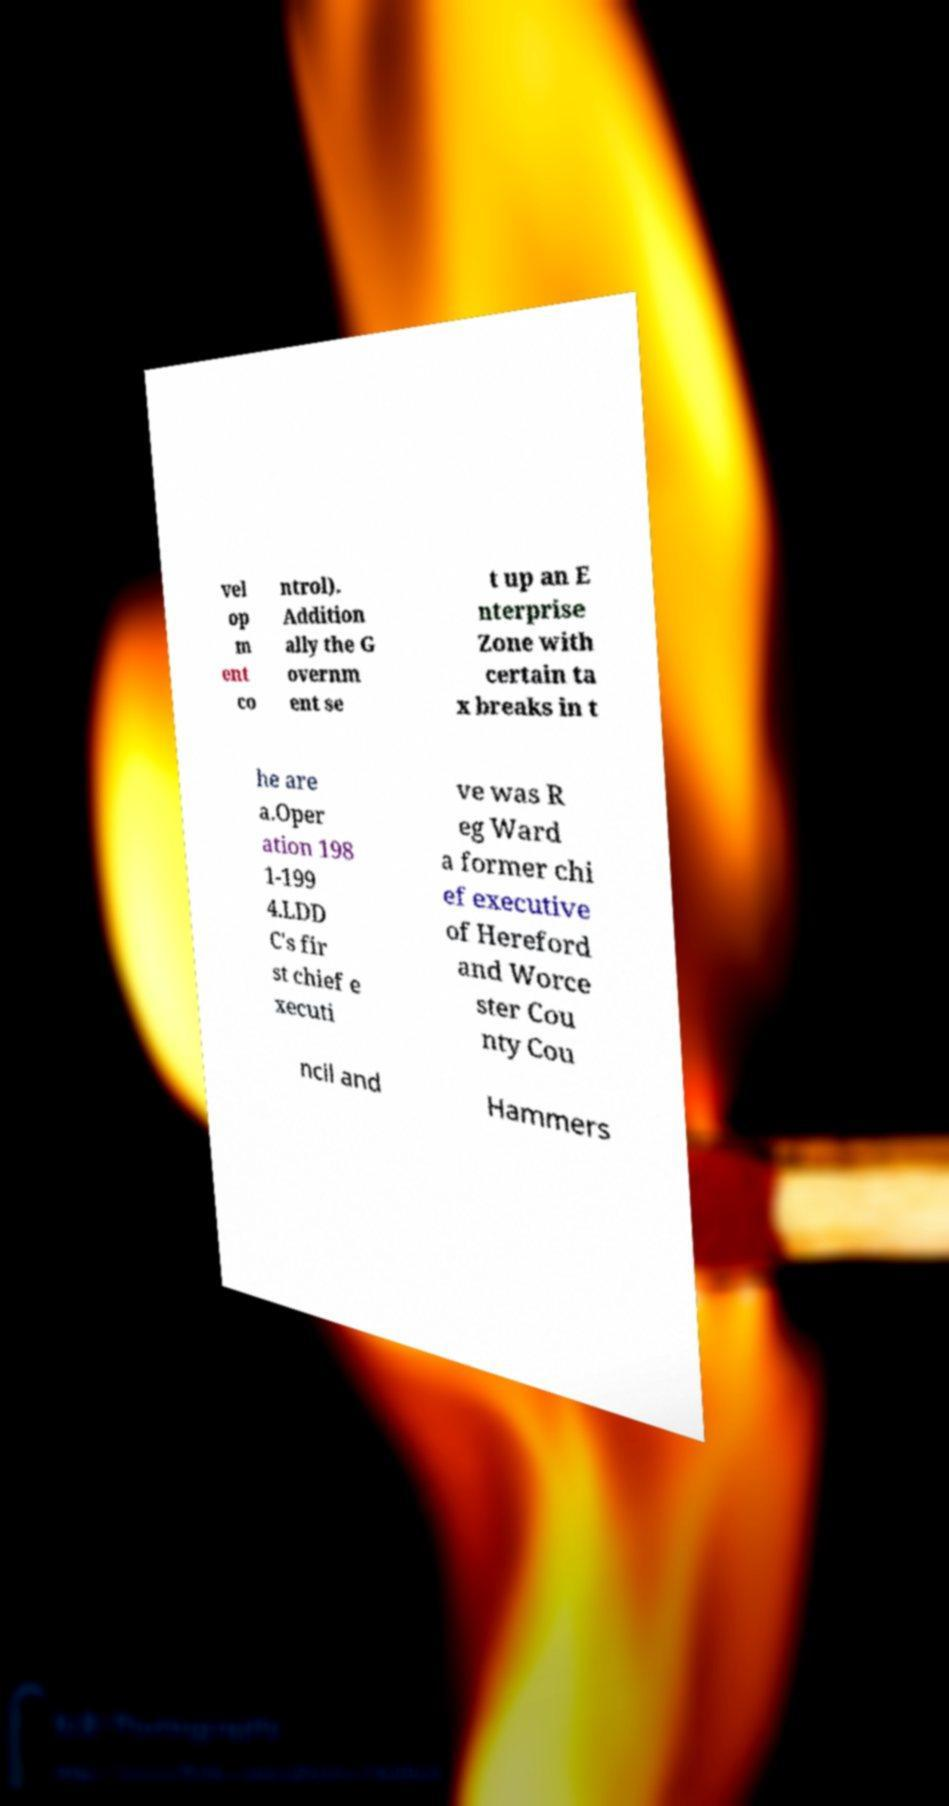Please read and relay the text visible in this image. What does it say? vel op m ent co ntrol). Addition ally the G overnm ent se t up an E nterprise Zone with certain ta x breaks in t he are a.Oper ation 198 1-199 4.LDD C's fir st chief e xecuti ve was R eg Ward a former chi ef executive of Hereford and Worce ster Cou nty Cou ncil and Hammers 